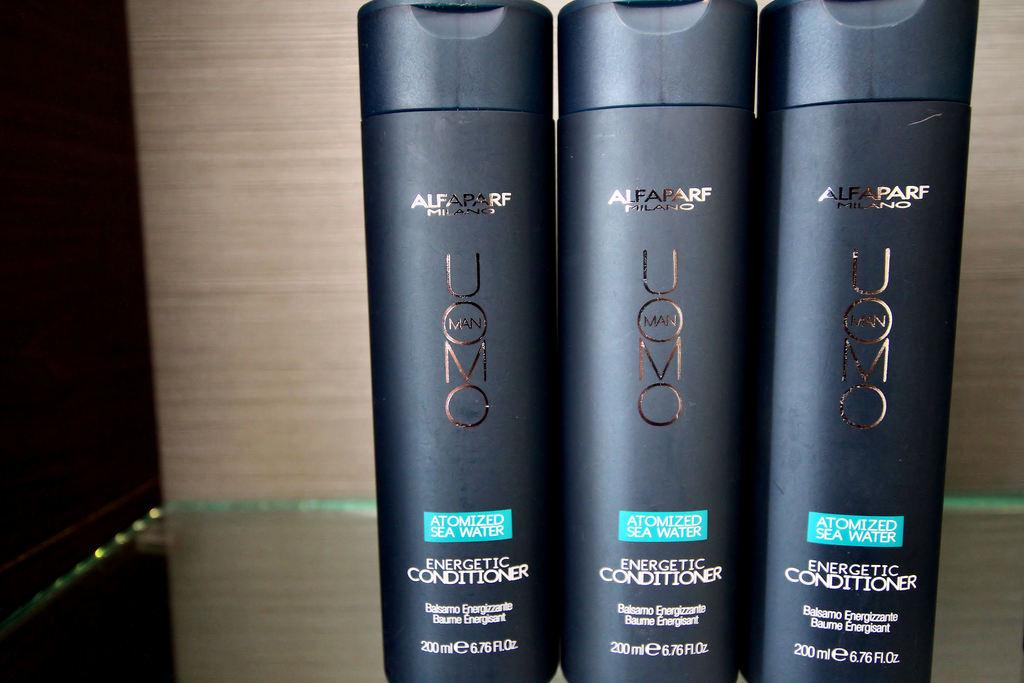<image>
Write a terse but informative summary of the picture. Three bottles of Uomo brand energetic conditioner sit together on a glass shelf. 